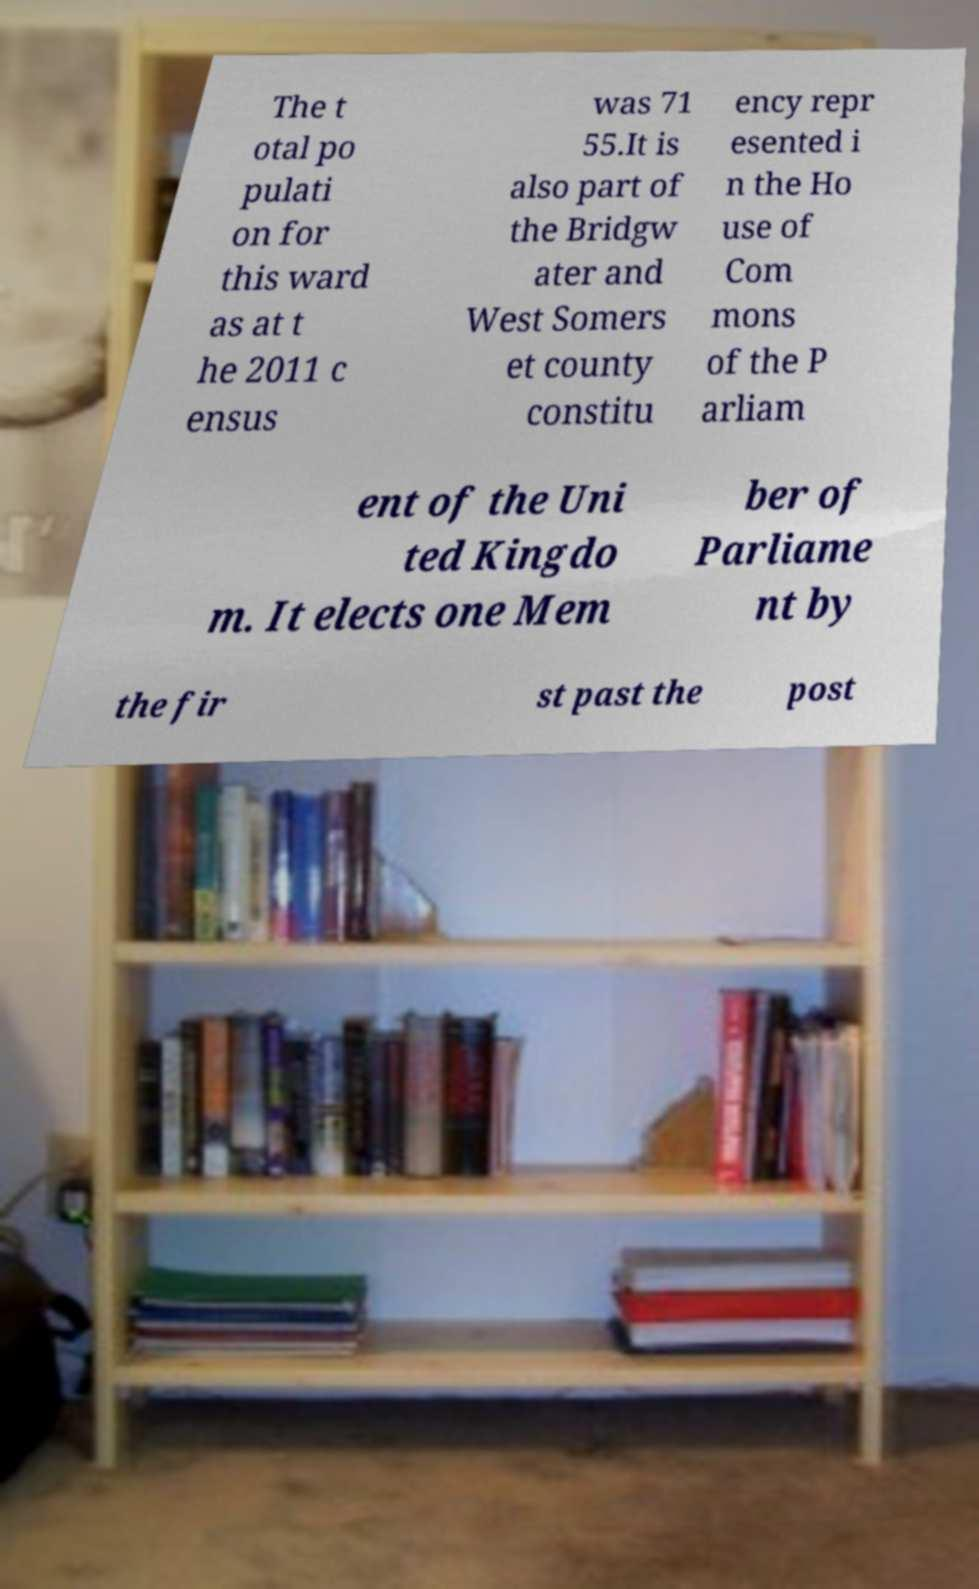For documentation purposes, I need the text within this image transcribed. Could you provide that? The t otal po pulati on for this ward as at t he 2011 c ensus was 71 55.It is also part of the Bridgw ater and West Somers et county constitu ency repr esented i n the Ho use of Com mons of the P arliam ent of the Uni ted Kingdo m. It elects one Mem ber of Parliame nt by the fir st past the post 